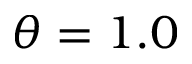<formula> <loc_0><loc_0><loc_500><loc_500>\theta = 1 . 0</formula> 